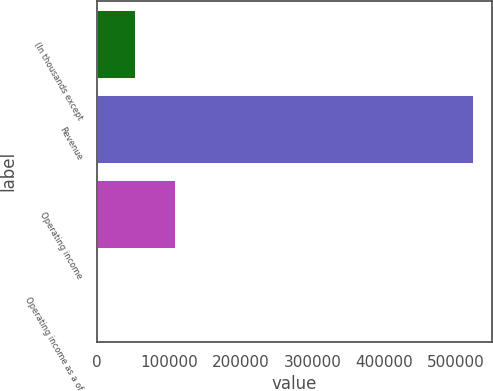<chart> <loc_0><loc_0><loc_500><loc_500><bar_chart><fcel>(In thousands except<fcel>Revenue<fcel>Operating income<fcel>Operating income as a of<nl><fcel>52369.8<fcel>523512<fcel>108370<fcel>20.7<nl></chart> 